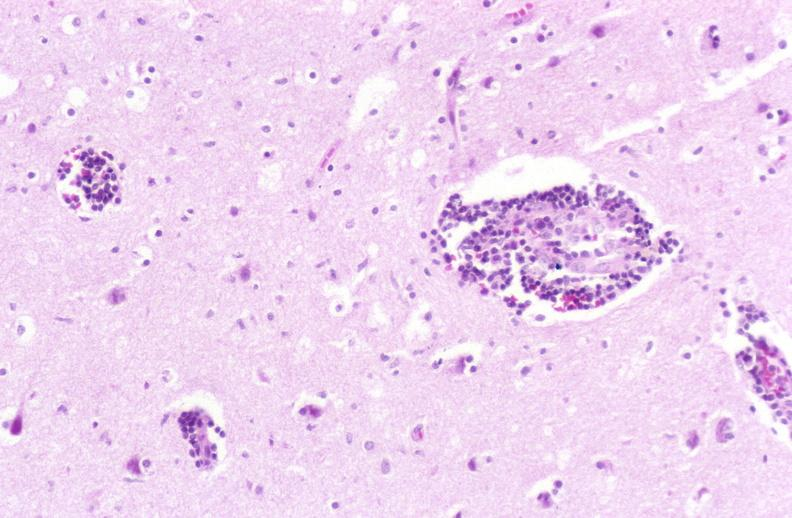what is present?
Answer the question using a single word or phrase. Nervous 